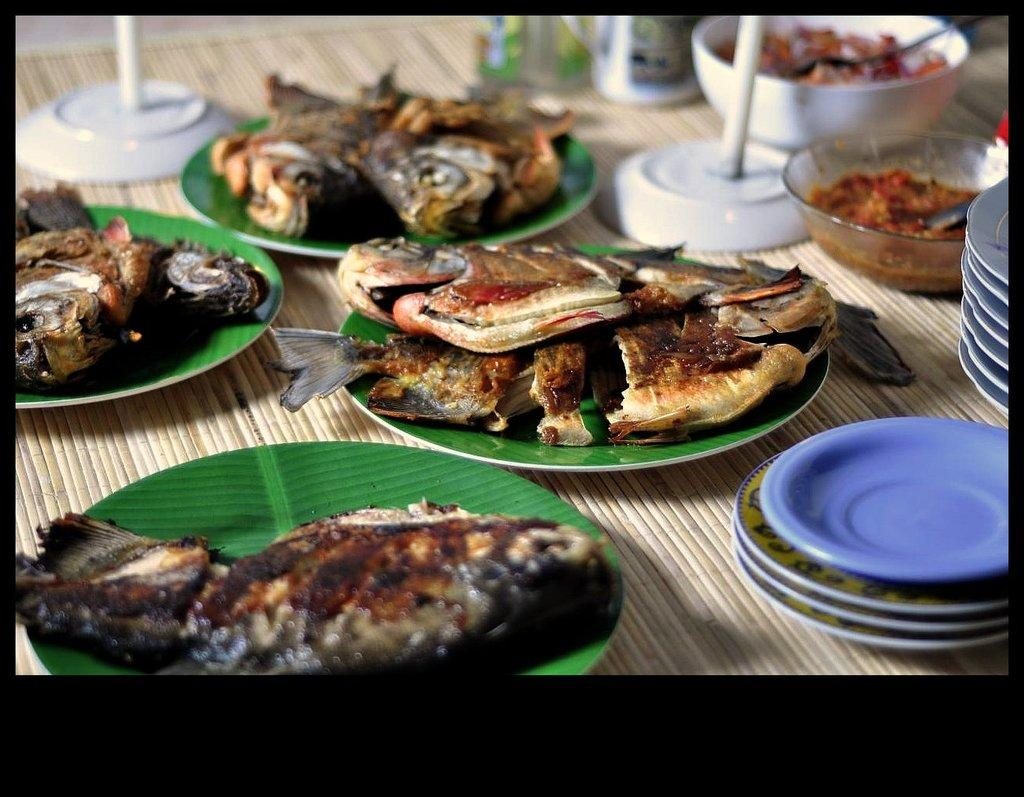What type of tableware can be seen on the table in the image? There are plates and bowls on the table in the image. What is on the plates and in the bowls? There is food on the plates and in the bowls. What type of utensils are used with the food in the bowls? There are spoons in the bowls. What specific type of food is on the plates? There is cooked fish on the plates. What type of brass instrument is being played in the image? There is no brass instrument present in the image; it features plates, bowls, and food. Can you describe the haircut of the person in the image? There is no person present in the image, only tableware and food. 